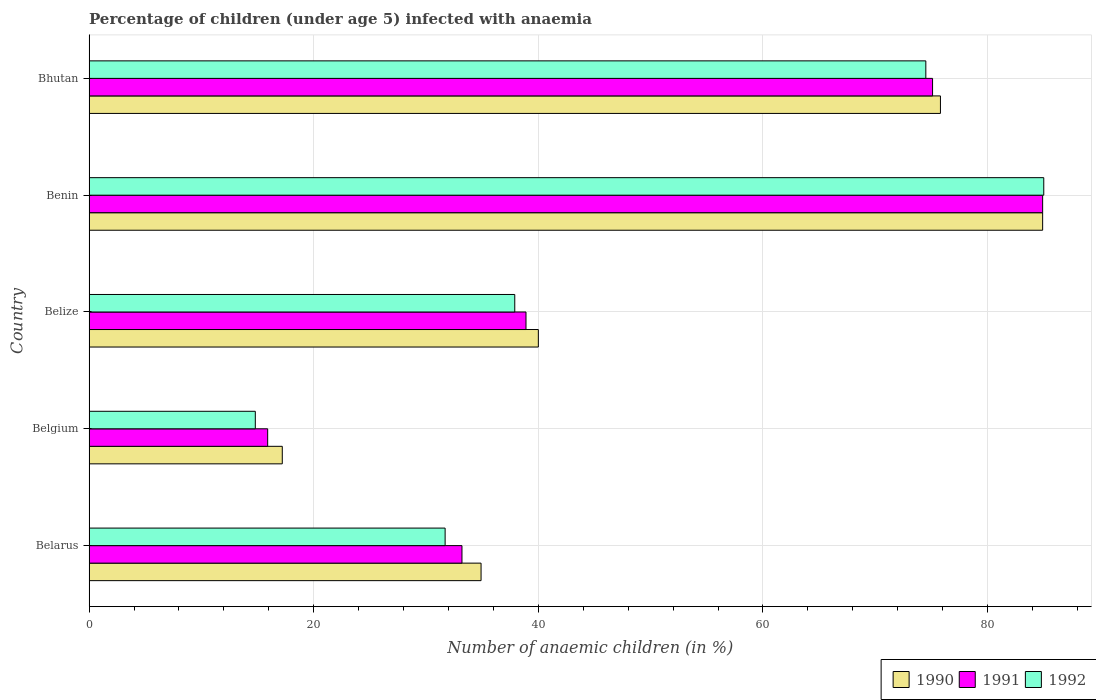Are the number of bars on each tick of the Y-axis equal?
Your answer should be compact. Yes. How many bars are there on the 5th tick from the top?
Give a very brief answer. 3. What is the label of the 4th group of bars from the top?
Your answer should be very brief. Belgium. Across all countries, what is the maximum percentage of children infected with anaemia in in 1991?
Ensure brevity in your answer.  84.9. In which country was the percentage of children infected with anaemia in in 1990 maximum?
Make the answer very short. Benin. In which country was the percentage of children infected with anaemia in in 1991 minimum?
Your answer should be compact. Belgium. What is the total percentage of children infected with anaemia in in 1991 in the graph?
Your answer should be compact. 248. What is the difference between the percentage of children infected with anaemia in in 1991 in Belize and that in Benin?
Keep it short and to the point. -46. What is the difference between the percentage of children infected with anaemia in in 1990 in Belarus and the percentage of children infected with anaemia in in 1992 in Belgium?
Provide a succinct answer. 20.1. What is the average percentage of children infected with anaemia in in 1990 per country?
Give a very brief answer. 50.56. What is the difference between the percentage of children infected with anaemia in in 1990 and percentage of children infected with anaemia in in 1992 in Bhutan?
Provide a succinct answer. 1.3. In how many countries, is the percentage of children infected with anaemia in in 1990 greater than 56 %?
Provide a short and direct response. 2. What is the ratio of the percentage of children infected with anaemia in in 1990 in Belarus to that in Belgium?
Offer a very short reply. 2.03. Is the percentage of children infected with anaemia in in 1991 in Belgium less than that in Bhutan?
Provide a succinct answer. Yes. Is the difference between the percentage of children infected with anaemia in in 1990 in Belarus and Benin greater than the difference between the percentage of children infected with anaemia in in 1992 in Belarus and Benin?
Offer a very short reply. Yes. In how many countries, is the percentage of children infected with anaemia in in 1991 greater than the average percentage of children infected with anaemia in in 1991 taken over all countries?
Offer a very short reply. 2. What does the 2nd bar from the top in Belize represents?
Offer a terse response. 1991. What does the 2nd bar from the bottom in Belarus represents?
Provide a short and direct response. 1991. Is it the case that in every country, the sum of the percentage of children infected with anaemia in in 1990 and percentage of children infected with anaemia in in 1991 is greater than the percentage of children infected with anaemia in in 1992?
Your answer should be compact. Yes. How many bars are there?
Keep it short and to the point. 15. How many countries are there in the graph?
Offer a terse response. 5. What is the difference between two consecutive major ticks on the X-axis?
Your answer should be compact. 20. What is the title of the graph?
Offer a very short reply. Percentage of children (under age 5) infected with anaemia. What is the label or title of the X-axis?
Ensure brevity in your answer.  Number of anaemic children (in %). What is the label or title of the Y-axis?
Give a very brief answer. Country. What is the Number of anaemic children (in %) of 1990 in Belarus?
Your answer should be compact. 34.9. What is the Number of anaemic children (in %) in 1991 in Belarus?
Provide a short and direct response. 33.2. What is the Number of anaemic children (in %) in 1992 in Belarus?
Give a very brief answer. 31.7. What is the Number of anaemic children (in %) in 1990 in Belize?
Your answer should be compact. 40. What is the Number of anaemic children (in %) in 1991 in Belize?
Give a very brief answer. 38.9. What is the Number of anaemic children (in %) of 1992 in Belize?
Your response must be concise. 37.9. What is the Number of anaemic children (in %) of 1990 in Benin?
Keep it short and to the point. 84.9. What is the Number of anaemic children (in %) in 1991 in Benin?
Keep it short and to the point. 84.9. What is the Number of anaemic children (in %) of 1992 in Benin?
Your answer should be very brief. 85. What is the Number of anaemic children (in %) in 1990 in Bhutan?
Your answer should be compact. 75.8. What is the Number of anaemic children (in %) of 1991 in Bhutan?
Your response must be concise. 75.1. What is the Number of anaemic children (in %) of 1992 in Bhutan?
Offer a very short reply. 74.5. Across all countries, what is the maximum Number of anaemic children (in %) of 1990?
Offer a very short reply. 84.9. Across all countries, what is the maximum Number of anaemic children (in %) of 1991?
Offer a terse response. 84.9. Across all countries, what is the maximum Number of anaemic children (in %) of 1992?
Offer a terse response. 85. Across all countries, what is the minimum Number of anaemic children (in %) of 1992?
Your answer should be compact. 14.8. What is the total Number of anaemic children (in %) in 1990 in the graph?
Keep it short and to the point. 252.8. What is the total Number of anaemic children (in %) in 1991 in the graph?
Your answer should be compact. 248. What is the total Number of anaemic children (in %) in 1992 in the graph?
Offer a terse response. 243.9. What is the difference between the Number of anaemic children (in %) of 1990 in Belarus and that in Belgium?
Offer a very short reply. 17.7. What is the difference between the Number of anaemic children (in %) of 1991 in Belarus and that in Belgium?
Keep it short and to the point. 17.3. What is the difference between the Number of anaemic children (in %) in 1992 in Belarus and that in Belgium?
Ensure brevity in your answer.  16.9. What is the difference between the Number of anaemic children (in %) in 1990 in Belarus and that in Belize?
Your answer should be compact. -5.1. What is the difference between the Number of anaemic children (in %) of 1992 in Belarus and that in Belize?
Provide a succinct answer. -6.2. What is the difference between the Number of anaemic children (in %) in 1991 in Belarus and that in Benin?
Your answer should be compact. -51.7. What is the difference between the Number of anaemic children (in %) of 1992 in Belarus and that in Benin?
Ensure brevity in your answer.  -53.3. What is the difference between the Number of anaemic children (in %) of 1990 in Belarus and that in Bhutan?
Ensure brevity in your answer.  -40.9. What is the difference between the Number of anaemic children (in %) of 1991 in Belarus and that in Bhutan?
Your answer should be compact. -41.9. What is the difference between the Number of anaemic children (in %) of 1992 in Belarus and that in Bhutan?
Provide a succinct answer. -42.8. What is the difference between the Number of anaemic children (in %) in 1990 in Belgium and that in Belize?
Give a very brief answer. -22.8. What is the difference between the Number of anaemic children (in %) in 1991 in Belgium and that in Belize?
Offer a terse response. -23. What is the difference between the Number of anaemic children (in %) in 1992 in Belgium and that in Belize?
Keep it short and to the point. -23.1. What is the difference between the Number of anaemic children (in %) in 1990 in Belgium and that in Benin?
Provide a short and direct response. -67.7. What is the difference between the Number of anaemic children (in %) in 1991 in Belgium and that in Benin?
Provide a succinct answer. -69. What is the difference between the Number of anaemic children (in %) in 1992 in Belgium and that in Benin?
Ensure brevity in your answer.  -70.2. What is the difference between the Number of anaemic children (in %) in 1990 in Belgium and that in Bhutan?
Ensure brevity in your answer.  -58.6. What is the difference between the Number of anaemic children (in %) in 1991 in Belgium and that in Bhutan?
Offer a very short reply. -59.2. What is the difference between the Number of anaemic children (in %) in 1992 in Belgium and that in Bhutan?
Offer a terse response. -59.7. What is the difference between the Number of anaemic children (in %) in 1990 in Belize and that in Benin?
Your response must be concise. -44.9. What is the difference between the Number of anaemic children (in %) in 1991 in Belize and that in Benin?
Give a very brief answer. -46. What is the difference between the Number of anaemic children (in %) of 1992 in Belize and that in Benin?
Give a very brief answer. -47.1. What is the difference between the Number of anaemic children (in %) of 1990 in Belize and that in Bhutan?
Keep it short and to the point. -35.8. What is the difference between the Number of anaemic children (in %) in 1991 in Belize and that in Bhutan?
Your response must be concise. -36.2. What is the difference between the Number of anaemic children (in %) in 1992 in Belize and that in Bhutan?
Offer a very short reply. -36.6. What is the difference between the Number of anaemic children (in %) of 1991 in Benin and that in Bhutan?
Keep it short and to the point. 9.8. What is the difference between the Number of anaemic children (in %) of 1990 in Belarus and the Number of anaemic children (in %) of 1992 in Belgium?
Offer a terse response. 20.1. What is the difference between the Number of anaemic children (in %) of 1990 in Belarus and the Number of anaemic children (in %) of 1991 in Belize?
Make the answer very short. -4. What is the difference between the Number of anaemic children (in %) in 1990 in Belarus and the Number of anaemic children (in %) in 1992 in Belize?
Offer a very short reply. -3. What is the difference between the Number of anaemic children (in %) in 1990 in Belarus and the Number of anaemic children (in %) in 1991 in Benin?
Give a very brief answer. -50. What is the difference between the Number of anaemic children (in %) of 1990 in Belarus and the Number of anaemic children (in %) of 1992 in Benin?
Give a very brief answer. -50.1. What is the difference between the Number of anaemic children (in %) in 1991 in Belarus and the Number of anaemic children (in %) in 1992 in Benin?
Make the answer very short. -51.8. What is the difference between the Number of anaemic children (in %) in 1990 in Belarus and the Number of anaemic children (in %) in 1991 in Bhutan?
Give a very brief answer. -40.2. What is the difference between the Number of anaemic children (in %) of 1990 in Belarus and the Number of anaemic children (in %) of 1992 in Bhutan?
Give a very brief answer. -39.6. What is the difference between the Number of anaemic children (in %) of 1991 in Belarus and the Number of anaemic children (in %) of 1992 in Bhutan?
Your response must be concise. -41.3. What is the difference between the Number of anaemic children (in %) of 1990 in Belgium and the Number of anaemic children (in %) of 1991 in Belize?
Your response must be concise. -21.7. What is the difference between the Number of anaemic children (in %) of 1990 in Belgium and the Number of anaemic children (in %) of 1992 in Belize?
Provide a succinct answer. -20.7. What is the difference between the Number of anaemic children (in %) in 1991 in Belgium and the Number of anaemic children (in %) in 1992 in Belize?
Provide a short and direct response. -22. What is the difference between the Number of anaemic children (in %) in 1990 in Belgium and the Number of anaemic children (in %) in 1991 in Benin?
Keep it short and to the point. -67.7. What is the difference between the Number of anaemic children (in %) in 1990 in Belgium and the Number of anaemic children (in %) in 1992 in Benin?
Give a very brief answer. -67.8. What is the difference between the Number of anaemic children (in %) of 1991 in Belgium and the Number of anaemic children (in %) of 1992 in Benin?
Give a very brief answer. -69.1. What is the difference between the Number of anaemic children (in %) in 1990 in Belgium and the Number of anaemic children (in %) in 1991 in Bhutan?
Offer a very short reply. -57.9. What is the difference between the Number of anaemic children (in %) in 1990 in Belgium and the Number of anaemic children (in %) in 1992 in Bhutan?
Ensure brevity in your answer.  -57.3. What is the difference between the Number of anaemic children (in %) of 1991 in Belgium and the Number of anaemic children (in %) of 1992 in Bhutan?
Give a very brief answer. -58.6. What is the difference between the Number of anaemic children (in %) in 1990 in Belize and the Number of anaemic children (in %) in 1991 in Benin?
Keep it short and to the point. -44.9. What is the difference between the Number of anaemic children (in %) in 1990 in Belize and the Number of anaemic children (in %) in 1992 in Benin?
Ensure brevity in your answer.  -45. What is the difference between the Number of anaemic children (in %) of 1991 in Belize and the Number of anaemic children (in %) of 1992 in Benin?
Ensure brevity in your answer.  -46.1. What is the difference between the Number of anaemic children (in %) of 1990 in Belize and the Number of anaemic children (in %) of 1991 in Bhutan?
Provide a succinct answer. -35.1. What is the difference between the Number of anaemic children (in %) in 1990 in Belize and the Number of anaemic children (in %) in 1992 in Bhutan?
Offer a very short reply. -34.5. What is the difference between the Number of anaemic children (in %) in 1991 in Belize and the Number of anaemic children (in %) in 1992 in Bhutan?
Keep it short and to the point. -35.6. What is the difference between the Number of anaemic children (in %) in 1990 in Benin and the Number of anaemic children (in %) in 1992 in Bhutan?
Provide a succinct answer. 10.4. What is the average Number of anaemic children (in %) of 1990 per country?
Give a very brief answer. 50.56. What is the average Number of anaemic children (in %) in 1991 per country?
Give a very brief answer. 49.6. What is the average Number of anaemic children (in %) of 1992 per country?
Offer a very short reply. 48.78. What is the difference between the Number of anaemic children (in %) in 1990 and Number of anaemic children (in %) in 1992 in Belarus?
Your answer should be compact. 3.2. What is the difference between the Number of anaemic children (in %) in 1990 and Number of anaemic children (in %) in 1991 in Belgium?
Make the answer very short. 1.3. What is the difference between the Number of anaemic children (in %) of 1990 and Number of anaemic children (in %) of 1991 in Belize?
Provide a succinct answer. 1.1. What is the difference between the Number of anaemic children (in %) in 1990 and Number of anaemic children (in %) in 1992 in Benin?
Offer a very short reply. -0.1. What is the difference between the Number of anaemic children (in %) in 1991 and Number of anaemic children (in %) in 1992 in Benin?
Your answer should be compact. -0.1. What is the difference between the Number of anaemic children (in %) in 1990 and Number of anaemic children (in %) in 1991 in Bhutan?
Provide a succinct answer. 0.7. What is the difference between the Number of anaemic children (in %) in 1991 and Number of anaemic children (in %) in 1992 in Bhutan?
Give a very brief answer. 0.6. What is the ratio of the Number of anaemic children (in %) in 1990 in Belarus to that in Belgium?
Offer a terse response. 2.03. What is the ratio of the Number of anaemic children (in %) in 1991 in Belarus to that in Belgium?
Offer a terse response. 2.09. What is the ratio of the Number of anaemic children (in %) of 1992 in Belarus to that in Belgium?
Offer a terse response. 2.14. What is the ratio of the Number of anaemic children (in %) in 1990 in Belarus to that in Belize?
Provide a short and direct response. 0.87. What is the ratio of the Number of anaemic children (in %) in 1991 in Belarus to that in Belize?
Ensure brevity in your answer.  0.85. What is the ratio of the Number of anaemic children (in %) in 1992 in Belarus to that in Belize?
Make the answer very short. 0.84. What is the ratio of the Number of anaemic children (in %) of 1990 in Belarus to that in Benin?
Your answer should be very brief. 0.41. What is the ratio of the Number of anaemic children (in %) in 1991 in Belarus to that in Benin?
Make the answer very short. 0.39. What is the ratio of the Number of anaemic children (in %) in 1992 in Belarus to that in Benin?
Offer a very short reply. 0.37. What is the ratio of the Number of anaemic children (in %) of 1990 in Belarus to that in Bhutan?
Make the answer very short. 0.46. What is the ratio of the Number of anaemic children (in %) of 1991 in Belarus to that in Bhutan?
Your response must be concise. 0.44. What is the ratio of the Number of anaemic children (in %) of 1992 in Belarus to that in Bhutan?
Offer a very short reply. 0.43. What is the ratio of the Number of anaemic children (in %) in 1990 in Belgium to that in Belize?
Offer a terse response. 0.43. What is the ratio of the Number of anaemic children (in %) in 1991 in Belgium to that in Belize?
Offer a very short reply. 0.41. What is the ratio of the Number of anaemic children (in %) in 1992 in Belgium to that in Belize?
Give a very brief answer. 0.39. What is the ratio of the Number of anaemic children (in %) in 1990 in Belgium to that in Benin?
Your answer should be very brief. 0.2. What is the ratio of the Number of anaemic children (in %) of 1991 in Belgium to that in Benin?
Your answer should be compact. 0.19. What is the ratio of the Number of anaemic children (in %) of 1992 in Belgium to that in Benin?
Keep it short and to the point. 0.17. What is the ratio of the Number of anaemic children (in %) in 1990 in Belgium to that in Bhutan?
Your answer should be compact. 0.23. What is the ratio of the Number of anaemic children (in %) in 1991 in Belgium to that in Bhutan?
Provide a succinct answer. 0.21. What is the ratio of the Number of anaemic children (in %) in 1992 in Belgium to that in Bhutan?
Your answer should be very brief. 0.2. What is the ratio of the Number of anaemic children (in %) in 1990 in Belize to that in Benin?
Your answer should be very brief. 0.47. What is the ratio of the Number of anaemic children (in %) of 1991 in Belize to that in Benin?
Keep it short and to the point. 0.46. What is the ratio of the Number of anaemic children (in %) in 1992 in Belize to that in Benin?
Your answer should be compact. 0.45. What is the ratio of the Number of anaemic children (in %) of 1990 in Belize to that in Bhutan?
Your answer should be very brief. 0.53. What is the ratio of the Number of anaemic children (in %) of 1991 in Belize to that in Bhutan?
Offer a terse response. 0.52. What is the ratio of the Number of anaemic children (in %) in 1992 in Belize to that in Bhutan?
Provide a succinct answer. 0.51. What is the ratio of the Number of anaemic children (in %) of 1990 in Benin to that in Bhutan?
Offer a very short reply. 1.12. What is the ratio of the Number of anaemic children (in %) of 1991 in Benin to that in Bhutan?
Ensure brevity in your answer.  1.13. What is the ratio of the Number of anaemic children (in %) in 1992 in Benin to that in Bhutan?
Your answer should be very brief. 1.14. What is the difference between the highest and the second highest Number of anaemic children (in %) of 1991?
Your response must be concise. 9.8. What is the difference between the highest and the second highest Number of anaemic children (in %) in 1992?
Keep it short and to the point. 10.5. What is the difference between the highest and the lowest Number of anaemic children (in %) in 1990?
Give a very brief answer. 67.7. What is the difference between the highest and the lowest Number of anaemic children (in %) in 1992?
Offer a terse response. 70.2. 